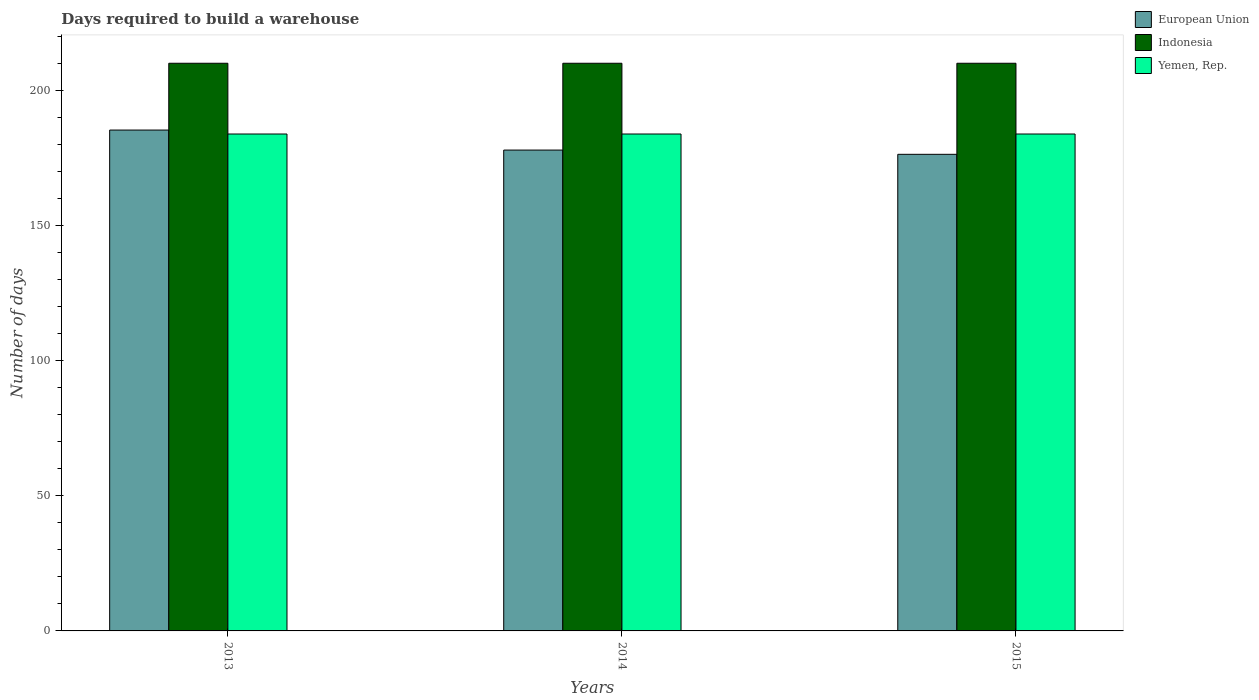How many groups of bars are there?
Provide a short and direct response. 3. Are the number of bars on each tick of the X-axis equal?
Keep it short and to the point. Yes. What is the label of the 3rd group of bars from the left?
Your answer should be compact. 2015. What is the days required to build a warehouse in in Indonesia in 2014?
Your answer should be compact. 210.2. Across all years, what is the maximum days required to build a warehouse in in European Union?
Offer a terse response. 185.46. Across all years, what is the minimum days required to build a warehouse in in Yemen, Rep.?
Make the answer very short. 184. What is the total days required to build a warehouse in in Yemen, Rep. in the graph?
Provide a succinct answer. 552. What is the difference between the days required to build a warehouse in in Indonesia in 2015 and the days required to build a warehouse in in European Union in 2013?
Your answer should be compact. 24.74. What is the average days required to build a warehouse in in Indonesia per year?
Ensure brevity in your answer.  210.2. In the year 2013, what is the difference between the days required to build a warehouse in in European Union and days required to build a warehouse in in Yemen, Rep.?
Provide a short and direct response. 1.46. In how many years, is the days required to build a warehouse in in Yemen, Rep. greater than 120 days?
Your answer should be compact. 3. What is the ratio of the days required to build a warehouse in in Yemen, Rep. in 2013 to that in 2015?
Provide a short and direct response. 1. Is the days required to build a warehouse in in Indonesia in 2013 less than that in 2015?
Keep it short and to the point. No. Is the difference between the days required to build a warehouse in in European Union in 2013 and 2014 greater than the difference between the days required to build a warehouse in in Yemen, Rep. in 2013 and 2014?
Keep it short and to the point. Yes. What is the difference between the highest and the lowest days required to build a warehouse in in Yemen, Rep.?
Make the answer very short. 0. In how many years, is the days required to build a warehouse in in European Union greater than the average days required to build a warehouse in in European Union taken over all years?
Give a very brief answer. 1. Is the sum of the days required to build a warehouse in in Indonesia in 2014 and 2015 greater than the maximum days required to build a warehouse in in Yemen, Rep. across all years?
Ensure brevity in your answer.  Yes. What does the 3rd bar from the left in 2013 represents?
Offer a terse response. Yemen, Rep. How many years are there in the graph?
Your response must be concise. 3. What is the difference between two consecutive major ticks on the Y-axis?
Offer a terse response. 50. Are the values on the major ticks of Y-axis written in scientific E-notation?
Offer a very short reply. No. Does the graph contain any zero values?
Make the answer very short. No. How many legend labels are there?
Your answer should be very brief. 3. How are the legend labels stacked?
Provide a short and direct response. Vertical. What is the title of the graph?
Keep it short and to the point. Days required to build a warehouse. What is the label or title of the Y-axis?
Make the answer very short. Number of days. What is the Number of days in European Union in 2013?
Keep it short and to the point. 185.46. What is the Number of days of Indonesia in 2013?
Offer a very short reply. 210.2. What is the Number of days of Yemen, Rep. in 2013?
Offer a very short reply. 184. What is the Number of days in European Union in 2014?
Your response must be concise. 178.05. What is the Number of days of Indonesia in 2014?
Offer a terse response. 210.2. What is the Number of days of Yemen, Rep. in 2014?
Your answer should be very brief. 184. What is the Number of days of European Union in 2015?
Offer a very short reply. 176.48. What is the Number of days of Indonesia in 2015?
Your answer should be very brief. 210.2. What is the Number of days of Yemen, Rep. in 2015?
Keep it short and to the point. 184. Across all years, what is the maximum Number of days in European Union?
Offer a very short reply. 185.46. Across all years, what is the maximum Number of days in Indonesia?
Offer a very short reply. 210.2. Across all years, what is the maximum Number of days of Yemen, Rep.?
Offer a very short reply. 184. Across all years, what is the minimum Number of days of European Union?
Your answer should be compact. 176.48. Across all years, what is the minimum Number of days of Indonesia?
Your answer should be compact. 210.2. Across all years, what is the minimum Number of days in Yemen, Rep.?
Make the answer very short. 184. What is the total Number of days of European Union in the graph?
Make the answer very short. 540. What is the total Number of days in Indonesia in the graph?
Ensure brevity in your answer.  630.6. What is the total Number of days of Yemen, Rep. in the graph?
Offer a very short reply. 552. What is the difference between the Number of days of European Union in 2013 and that in 2014?
Your response must be concise. 7.41. What is the difference between the Number of days of Indonesia in 2013 and that in 2014?
Offer a terse response. 0. What is the difference between the Number of days of Yemen, Rep. in 2013 and that in 2014?
Make the answer very short. 0. What is the difference between the Number of days of European Union in 2013 and that in 2015?
Your response must be concise. 8.98. What is the difference between the Number of days of Yemen, Rep. in 2013 and that in 2015?
Your answer should be compact. 0. What is the difference between the Number of days in European Union in 2014 and that in 2015?
Give a very brief answer. 1.57. What is the difference between the Number of days of European Union in 2013 and the Number of days of Indonesia in 2014?
Your answer should be compact. -24.74. What is the difference between the Number of days in European Union in 2013 and the Number of days in Yemen, Rep. in 2014?
Ensure brevity in your answer.  1.46. What is the difference between the Number of days in Indonesia in 2013 and the Number of days in Yemen, Rep. in 2014?
Provide a succinct answer. 26.2. What is the difference between the Number of days of European Union in 2013 and the Number of days of Indonesia in 2015?
Provide a short and direct response. -24.74. What is the difference between the Number of days in European Union in 2013 and the Number of days in Yemen, Rep. in 2015?
Your response must be concise. 1.46. What is the difference between the Number of days in Indonesia in 2013 and the Number of days in Yemen, Rep. in 2015?
Provide a short and direct response. 26.2. What is the difference between the Number of days in European Union in 2014 and the Number of days in Indonesia in 2015?
Provide a succinct answer. -32.15. What is the difference between the Number of days of European Union in 2014 and the Number of days of Yemen, Rep. in 2015?
Offer a terse response. -5.95. What is the difference between the Number of days of Indonesia in 2014 and the Number of days of Yemen, Rep. in 2015?
Provide a short and direct response. 26.2. What is the average Number of days in European Union per year?
Give a very brief answer. 180. What is the average Number of days in Indonesia per year?
Ensure brevity in your answer.  210.2. What is the average Number of days of Yemen, Rep. per year?
Offer a terse response. 184. In the year 2013, what is the difference between the Number of days in European Union and Number of days in Indonesia?
Provide a succinct answer. -24.74. In the year 2013, what is the difference between the Number of days of European Union and Number of days of Yemen, Rep.?
Your response must be concise. 1.46. In the year 2013, what is the difference between the Number of days in Indonesia and Number of days in Yemen, Rep.?
Give a very brief answer. 26.2. In the year 2014, what is the difference between the Number of days of European Union and Number of days of Indonesia?
Offer a very short reply. -32.15. In the year 2014, what is the difference between the Number of days in European Union and Number of days in Yemen, Rep.?
Your response must be concise. -5.95. In the year 2014, what is the difference between the Number of days of Indonesia and Number of days of Yemen, Rep.?
Keep it short and to the point. 26.2. In the year 2015, what is the difference between the Number of days of European Union and Number of days of Indonesia?
Give a very brief answer. -33.72. In the year 2015, what is the difference between the Number of days of European Union and Number of days of Yemen, Rep.?
Give a very brief answer. -7.52. In the year 2015, what is the difference between the Number of days of Indonesia and Number of days of Yemen, Rep.?
Your response must be concise. 26.2. What is the ratio of the Number of days of European Union in 2013 to that in 2014?
Your answer should be compact. 1.04. What is the ratio of the Number of days in Indonesia in 2013 to that in 2014?
Your answer should be compact. 1. What is the ratio of the Number of days of European Union in 2013 to that in 2015?
Ensure brevity in your answer.  1.05. What is the ratio of the Number of days in Indonesia in 2013 to that in 2015?
Your answer should be compact. 1. What is the ratio of the Number of days in Yemen, Rep. in 2013 to that in 2015?
Your response must be concise. 1. What is the ratio of the Number of days in European Union in 2014 to that in 2015?
Ensure brevity in your answer.  1.01. What is the difference between the highest and the second highest Number of days of European Union?
Ensure brevity in your answer.  7.41. What is the difference between the highest and the second highest Number of days in Yemen, Rep.?
Your answer should be very brief. 0. What is the difference between the highest and the lowest Number of days of European Union?
Offer a terse response. 8.98. What is the difference between the highest and the lowest Number of days in Yemen, Rep.?
Keep it short and to the point. 0. 